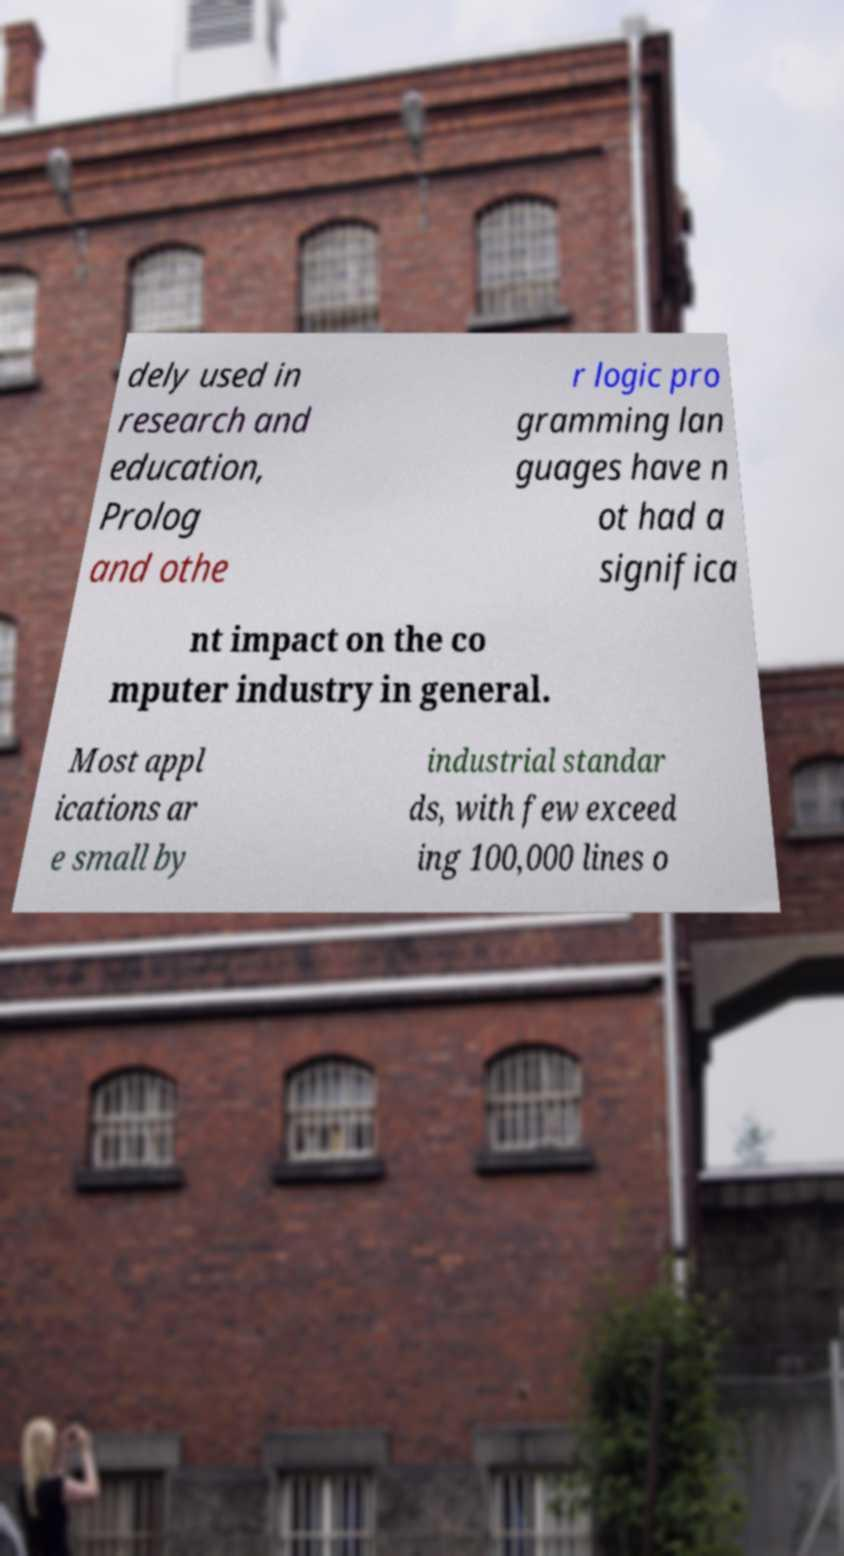What messages or text are displayed in this image? I need them in a readable, typed format. dely used in research and education, Prolog and othe r logic pro gramming lan guages have n ot had a significa nt impact on the co mputer industry in general. Most appl ications ar e small by industrial standar ds, with few exceed ing 100,000 lines o 